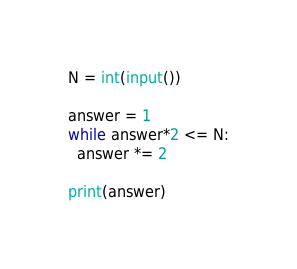Convert code to text. <code><loc_0><loc_0><loc_500><loc_500><_Python_>N = int(input())

answer = 1
while answer*2 <= N:
  answer *= 2
  
print(answer)</code> 